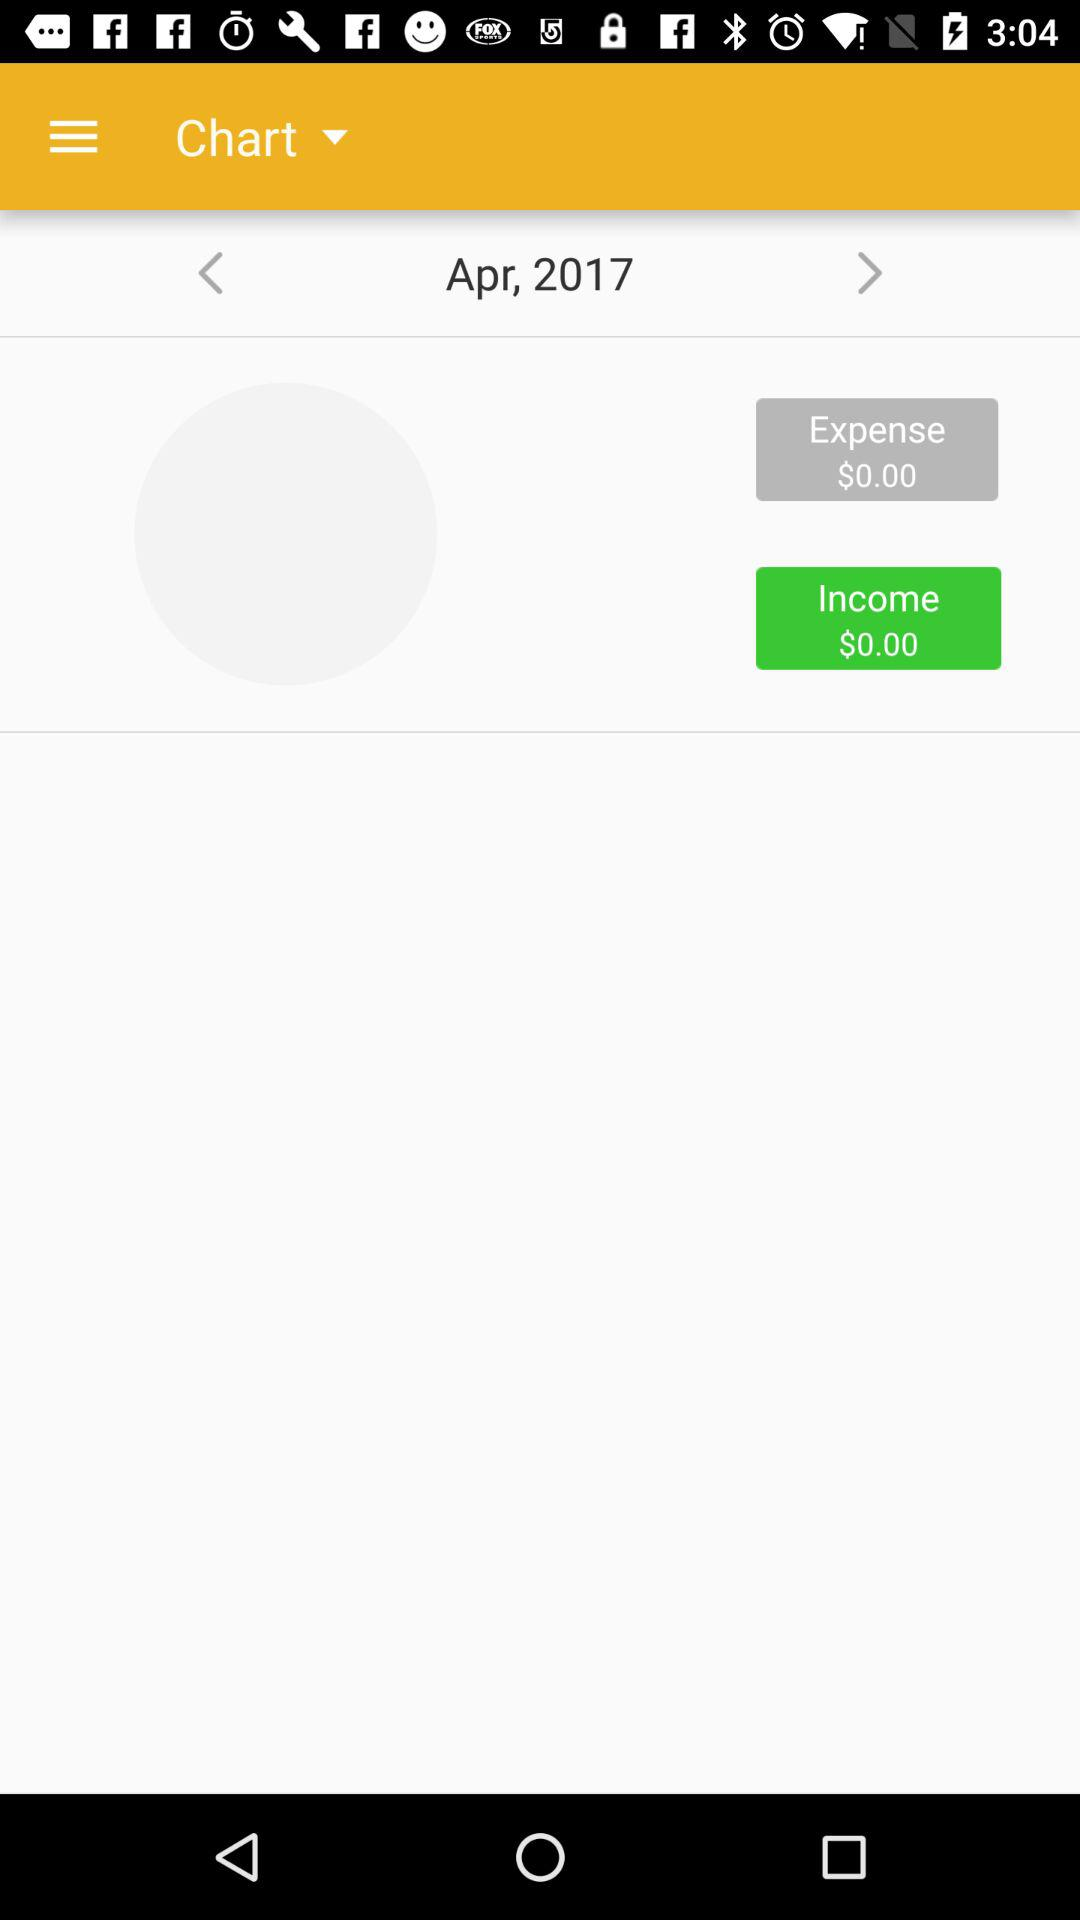What is the income? The income is $0. 